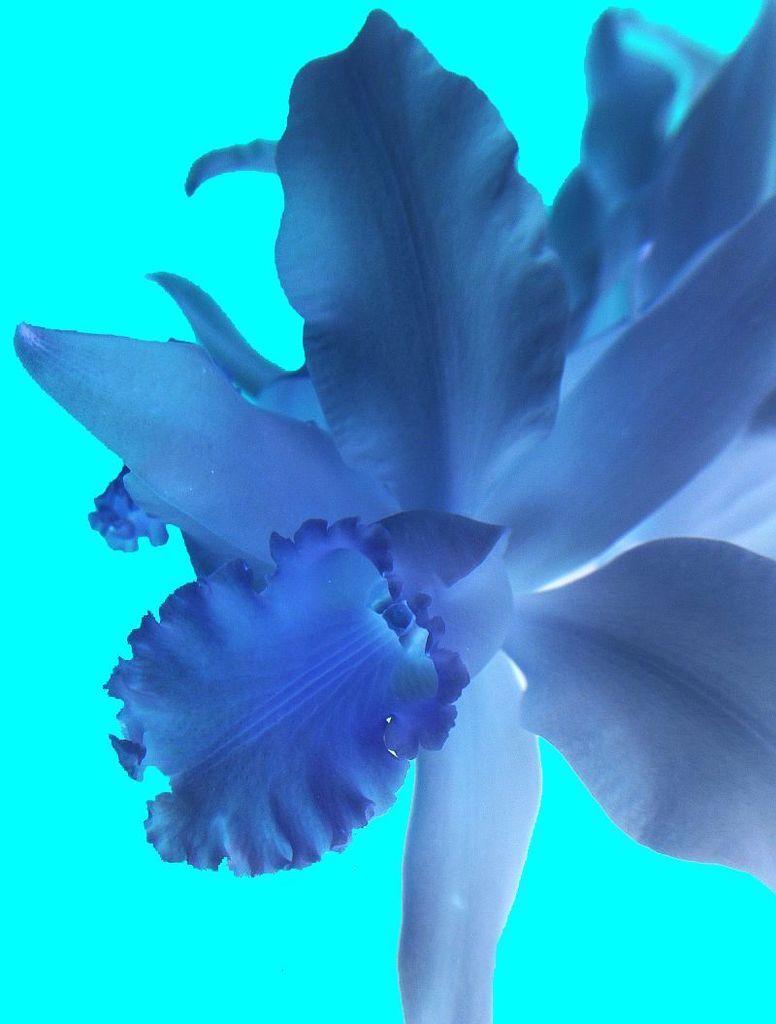In one or two sentences, can you explain what this image depicts? In this image I can see few blue colour things over here. 